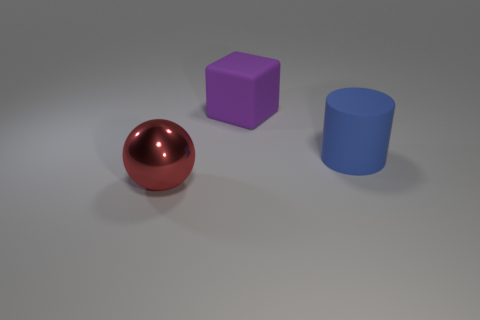Add 3 big cylinders. How many objects exist? 6 Subtract 1 cubes. How many cubes are left? 0 Subtract all green cylinders. Subtract all brown blocks. How many cylinders are left? 1 Subtract all red blocks. How many yellow spheres are left? 0 Subtract all large purple metal things. Subtract all big rubber objects. How many objects are left? 1 Add 1 blue objects. How many blue objects are left? 2 Add 3 large things. How many large things exist? 6 Subtract 0 brown balls. How many objects are left? 3 